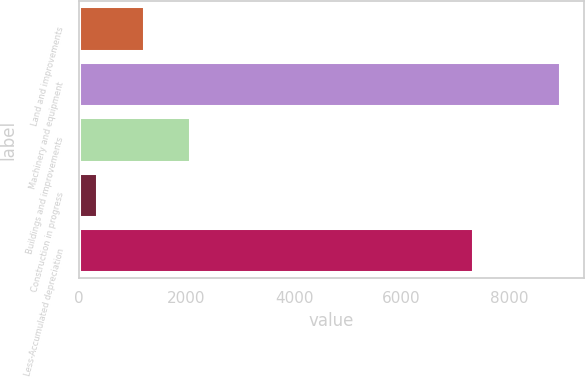<chart> <loc_0><loc_0><loc_500><loc_500><bar_chart><fcel>Land and improvements<fcel>Machinery and equipment<fcel>Buildings and improvements<fcel>Construction in progress<fcel>Less-Accumulated depreciation<nl><fcel>1203.1<fcel>8935<fcel>2062.2<fcel>344<fcel>7331<nl></chart> 